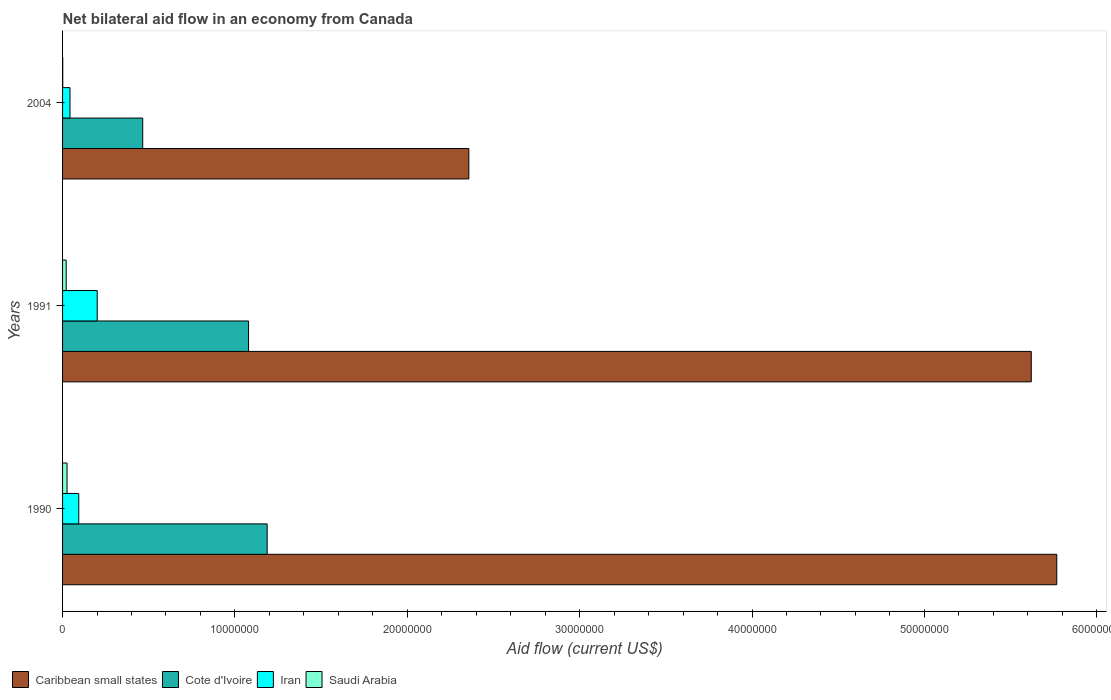How many different coloured bars are there?
Your answer should be compact. 4. What is the net bilateral aid flow in Cote d'Ivoire in 2004?
Provide a succinct answer. 4.65e+06. Across all years, what is the maximum net bilateral aid flow in Cote d'Ivoire?
Give a very brief answer. 1.19e+07. Across all years, what is the minimum net bilateral aid flow in Saudi Arabia?
Your answer should be compact. 10000. In which year was the net bilateral aid flow in Iran minimum?
Give a very brief answer. 2004. What is the total net bilateral aid flow in Caribbean small states in the graph?
Your answer should be very brief. 1.37e+08. What is the difference between the net bilateral aid flow in Saudi Arabia in 1991 and that in 2004?
Give a very brief answer. 2.00e+05. What is the difference between the net bilateral aid flow in Cote d'Ivoire in 2004 and the net bilateral aid flow in Caribbean small states in 1991?
Offer a very short reply. -5.16e+07. What is the average net bilateral aid flow in Saudi Arabia per year?
Keep it short and to the point. 1.60e+05. In the year 1991, what is the difference between the net bilateral aid flow in Iran and net bilateral aid flow in Saudi Arabia?
Offer a terse response. 1.80e+06. In how many years, is the net bilateral aid flow in Saudi Arabia greater than 30000000 US$?
Offer a terse response. 0. What is the ratio of the net bilateral aid flow in Saudi Arabia in 1990 to that in 1991?
Give a very brief answer. 1.24. What is the difference between the highest and the lowest net bilateral aid flow in Caribbean small states?
Ensure brevity in your answer.  3.41e+07. Is it the case that in every year, the sum of the net bilateral aid flow in Iran and net bilateral aid flow in Caribbean small states is greater than the sum of net bilateral aid flow in Cote d'Ivoire and net bilateral aid flow in Saudi Arabia?
Provide a short and direct response. Yes. What does the 3rd bar from the top in 1991 represents?
Your answer should be very brief. Cote d'Ivoire. What does the 2nd bar from the bottom in 2004 represents?
Keep it short and to the point. Cote d'Ivoire. How many bars are there?
Your answer should be compact. 12. How many years are there in the graph?
Make the answer very short. 3. What is the difference between two consecutive major ticks on the X-axis?
Keep it short and to the point. 1.00e+07. Are the values on the major ticks of X-axis written in scientific E-notation?
Make the answer very short. No. Does the graph contain grids?
Provide a succinct answer. No. How many legend labels are there?
Provide a succinct answer. 4. What is the title of the graph?
Make the answer very short. Net bilateral aid flow in an economy from Canada. Does "Slovenia" appear as one of the legend labels in the graph?
Provide a succinct answer. No. What is the label or title of the X-axis?
Your response must be concise. Aid flow (current US$). What is the Aid flow (current US$) in Caribbean small states in 1990?
Provide a short and direct response. 5.77e+07. What is the Aid flow (current US$) of Cote d'Ivoire in 1990?
Your answer should be very brief. 1.19e+07. What is the Aid flow (current US$) in Iran in 1990?
Ensure brevity in your answer.  9.40e+05. What is the Aid flow (current US$) of Caribbean small states in 1991?
Your response must be concise. 5.62e+07. What is the Aid flow (current US$) of Cote d'Ivoire in 1991?
Your answer should be compact. 1.08e+07. What is the Aid flow (current US$) of Iran in 1991?
Provide a succinct answer. 2.01e+06. What is the Aid flow (current US$) in Caribbean small states in 2004?
Provide a succinct answer. 2.36e+07. What is the Aid flow (current US$) of Cote d'Ivoire in 2004?
Your answer should be very brief. 4.65e+06. Across all years, what is the maximum Aid flow (current US$) of Caribbean small states?
Ensure brevity in your answer.  5.77e+07. Across all years, what is the maximum Aid flow (current US$) in Cote d'Ivoire?
Provide a succinct answer. 1.19e+07. Across all years, what is the maximum Aid flow (current US$) in Iran?
Offer a terse response. 2.01e+06. Across all years, what is the maximum Aid flow (current US$) in Saudi Arabia?
Offer a terse response. 2.60e+05. Across all years, what is the minimum Aid flow (current US$) of Caribbean small states?
Offer a very short reply. 2.36e+07. Across all years, what is the minimum Aid flow (current US$) of Cote d'Ivoire?
Provide a short and direct response. 4.65e+06. Across all years, what is the minimum Aid flow (current US$) of Iran?
Your response must be concise. 4.30e+05. Across all years, what is the minimum Aid flow (current US$) in Saudi Arabia?
Provide a short and direct response. 10000. What is the total Aid flow (current US$) in Caribbean small states in the graph?
Keep it short and to the point. 1.37e+08. What is the total Aid flow (current US$) in Cote d'Ivoire in the graph?
Your answer should be compact. 2.73e+07. What is the total Aid flow (current US$) of Iran in the graph?
Offer a terse response. 3.38e+06. What is the difference between the Aid flow (current US$) of Caribbean small states in 1990 and that in 1991?
Your answer should be very brief. 1.48e+06. What is the difference between the Aid flow (current US$) of Cote d'Ivoire in 1990 and that in 1991?
Provide a succinct answer. 1.08e+06. What is the difference between the Aid flow (current US$) of Iran in 1990 and that in 1991?
Give a very brief answer. -1.07e+06. What is the difference between the Aid flow (current US$) in Caribbean small states in 1990 and that in 2004?
Provide a short and direct response. 3.41e+07. What is the difference between the Aid flow (current US$) of Cote d'Ivoire in 1990 and that in 2004?
Your answer should be compact. 7.22e+06. What is the difference between the Aid flow (current US$) of Iran in 1990 and that in 2004?
Provide a short and direct response. 5.10e+05. What is the difference between the Aid flow (current US$) in Caribbean small states in 1991 and that in 2004?
Your answer should be compact. 3.26e+07. What is the difference between the Aid flow (current US$) of Cote d'Ivoire in 1991 and that in 2004?
Keep it short and to the point. 6.14e+06. What is the difference between the Aid flow (current US$) of Iran in 1991 and that in 2004?
Offer a terse response. 1.58e+06. What is the difference between the Aid flow (current US$) in Caribbean small states in 1990 and the Aid flow (current US$) in Cote d'Ivoire in 1991?
Provide a succinct answer. 4.69e+07. What is the difference between the Aid flow (current US$) of Caribbean small states in 1990 and the Aid flow (current US$) of Iran in 1991?
Provide a succinct answer. 5.57e+07. What is the difference between the Aid flow (current US$) of Caribbean small states in 1990 and the Aid flow (current US$) of Saudi Arabia in 1991?
Give a very brief answer. 5.75e+07. What is the difference between the Aid flow (current US$) of Cote d'Ivoire in 1990 and the Aid flow (current US$) of Iran in 1991?
Ensure brevity in your answer.  9.86e+06. What is the difference between the Aid flow (current US$) in Cote d'Ivoire in 1990 and the Aid flow (current US$) in Saudi Arabia in 1991?
Your answer should be very brief. 1.17e+07. What is the difference between the Aid flow (current US$) in Iran in 1990 and the Aid flow (current US$) in Saudi Arabia in 1991?
Keep it short and to the point. 7.30e+05. What is the difference between the Aid flow (current US$) in Caribbean small states in 1990 and the Aid flow (current US$) in Cote d'Ivoire in 2004?
Your response must be concise. 5.30e+07. What is the difference between the Aid flow (current US$) in Caribbean small states in 1990 and the Aid flow (current US$) in Iran in 2004?
Offer a terse response. 5.72e+07. What is the difference between the Aid flow (current US$) of Caribbean small states in 1990 and the Aid flow (current US$) of Saudi Arabia in 2004?
Keep it short and to the point. 5.77e+07. What is the difference between the Aid flow (current US$) of Cote d'Ivoire in 1990 and the Aid flow (current US$) of Iran in 2004?
Offer a very short reply. 1.14e+07. What is the difference between the Aid flow (current US$) in Cote d'Ivoire in 1990 and the Aid flow (current US$) in Saudi Arabia in 2004?
Keep it short and to the point. 1.19e+07. What is the difference between the Aid flow (current US$) of Iran in 1990 and the Aid flow (current US$) of Saudi Arabia in 2004?
Your answer should be compact. 9.30e+05. What is the difference between the Aid flow (current US$) in Caribbean small states in 1991 and the Aid flow (current US$) in Cote d'Ivoire in 2004?
Offer a terse response. 5.16e+07. What is the difference between the Aid flow (current US$) of Caribbean small states in 1991 and the Aid flow (current US$) of Iran in 2004?
Your answer should be compact. 5.58e+07. What is the difference between the Aid flow (current US$) of Caribbean small states in 1991 and the Aid flow (current US$) of Saudi Arabia in 2004?
Provide a succinct answer. 5.62e+07. What is the difference between the Aid flow (current US$) of Cote d'Ivoire in 1991 and the Aid flow (current US$) of Iran in 2004?
Keep it short and to the point. 1.04e+07. What is the difference between the Aid flow (current US$) of Cote d'Ivoire in 1991 and the Aid flow (current US$) of Saudi Arabia in 2004?
Offer a terse response. 1.08e+07. What is the average Aid flow (current US$) of Caribbean small states per year?
Keep it short and to the point. 4.58e+07. What is the average Aid flow (current US$) in Cote d'Ivoire per year?
Offer a very short reply. 9.10e+06. What is the average Aid flow (current US$) of Iran per year?
Keep it short and to the point. 1.13e+06. What is the average Aid flow (current US$) in Saudi Arabia per year?
Your answer should be very brief. 1.60e+05. In the year 1990, what is the difference between the Aid flow (current US$) in Caribbean small states and Aid flow (current US$) in Cote d'Ivoire?
Your answer should be very brief. 4.58e+07. In the year 1990, what is the difference between the Aid flow (current US$) in Caribbean small states and Aid flow (current US$) in Iran?
Your answer should be very brief. 5.67e+07. In the year 1990, what is the difference between the Aid flow (current US$) in Caribbean small states and Aid flow (current US$) in Saudi Arabia?
Keep it short and to the point. 5.74e+07. In the year 1990, what is the difference between the Aid flow (current US$) of Cote d'Ivoire and Aid flow (current US$) of Iran?
Ensure brevity in your answer.  1.09e+07. In the year 1990, what is the difference between the Aid flow (current US$) in Cote d'Ivoire and Aid flow (current US$) in Saudi Arabia?
Keep it short and to the point. 1.16e+07. In the year 1990, what is the difference between the Aid flow (current US$) in Iran and Aid flow (current US$) in Saudi Arabia?
Your response must be concise. 6.80e+05. In the year 1991, what is the difference between the Aid flow (current US$) in Caribbean small states and Aid flow (current US$) in Cote d'Ivoire?
Give a very brief answer. 4.54e+07. In the year 1991, what is the difference between the Aid flow (current US$) in Caribbean small states and Aid flow (current US$) in Iran?
Your answer should be compact. 5.42e+07. In the year 1991, what is the difference between the Aid flow (current US$) of Caribbean small states and Aid flow (current US$) of Saudi Arabia?
Make the answer very short. 5.60e+07. In the year 1991, what is the difference between the Aid flow (current US$) of Cote d'Ivoire and Aid flow (current US$) of Iran?
Make the answer very short. 8.78e+06. In the year 1991, what is the difference between the Aid flow (current US$) in Cote d'Ivoire and Aid flow (current US$) in Saudi Arabia?
Ensure brevity in your answer.  1.06e+07. In the year 1991, what is the difference between the Aid flow (current US$) in Iran and Aid flow (current US$) in Saudi Arabia?
Keep it short and to the point. 1.80e+06. In the year 2004, what is the difference between the Aid flow (current US$) in Caribbean small states and Aid flow (current US$) in Cote d'Ivoire?
Your answer should be compact. 1.89e+07. In the year 2004, what is the difference between the Aid flow (current US$) of Caribbean small states and Aid flow (current US$) of Iran?
Keep it short and to the point. 2.31e+07. In the year 2004, what is the difference between the Aid flow (current US$) in Caribbean small states and Aid flow (current US$) in Saudi Arabia?
Make the answer very short. 2.36e+07. In the year 2004, what is the difference between the Aid flow (current US$) of Cote d'Ivoire and Aid flow (current US$) of Iran?
Your answer should be compact. 4.22e+06. In the year 2004, what is the difference between the Aid flow (current US$) of Cote d'Ivoire and Aid flow (current US$) of Saudi Arabia?
Provide a short and direct response. 4.64e+06. In the year 2004, what is the difference between the Aid flow (current US$) in Iran and Aid flow (current US$) in Saudi Arabia?
Provide a short and direct response. 4.20e+05. What is the ratio of the Aid flow (current US$) of Caribbean small states in 1990 to that in 1991?
Your answer should be very brief. 1.03. What is the ratio of the Aid flow (current US$) in Cote d'Ivoire in 1990 to that in 1991?
Offer a terse response. 1.1. What is the ratio of the Aid flow (current US$) in Iran in 1990 to that in 1991?
Ensure brevity in your answer.  0.47. What is the ratio of the Aid flow (current US$) of Saudi Arabia in 1990 to that in 1991?
Offer a terse response. 1.24. What is the ratio of the Aid flow (current US$) in Caribbean small states in 1990 to that in 2004?
Your response must be concise. 2.45. What is the ratio of the Aid flow (current US$) in Cote d'Ivoire in 1990 to that in 2004?
Your response must be concise. 2.55. What is the ratio of the Aid flow (current US$) of Iran in 1990 to that in 2004?
Offer a very short reply. 2.19. What is the ratio of the Aid flow (current US$) in Saudi Arabia in 1990 to that in 2004?
Your answer should be very brief. 26. What is the ratio of the Aid flow (current US$) in Caribbean small states in 1991 to that in 2004?
Offer a very short reply. 2.38. What is the ratio of the Aid flow (current US$) in Cote d'Ivoire in 1991 to that in 2004?
Offer a very short reply. 2.32. What is the ratio of the Aid flow (current US$) of Iran in 1991 to that in 2004?
Provide a short and direct response. 4.67. What is the ratio of the Aid flow (current US$) in Saudi Arabia in 1991 to that in 2004?
Ensure brevity in your answer.  21. What is the difference between the highest and the second highest Aid flow (current US$) of Caribbean small states?
Your response must be concise. 1.48e+06. What is the difference between the highest and the second highest Aid flow (current US$) in Cote d'Ivoire?
Your response must be concise. 1.08e+06. What is the difference between the highest and the second highest Aid flow (current US$) of Iran?
Keep it short and to the point. 1.07e+06. What is the difference between the highest and the lowest Aid flow (current US$) of Caribbean small states?
Give a very brief answer. 3.41e+07. What is the difference between the highest and the lowest Aid flow (current US$) of Cote d'Ivoire?
Your answer should be very brief. 7.22e+06. What is the difference between the highest and the lowest Aid flow (current US$) in Iran?
Give a very brief answer. 1.58e+06. 